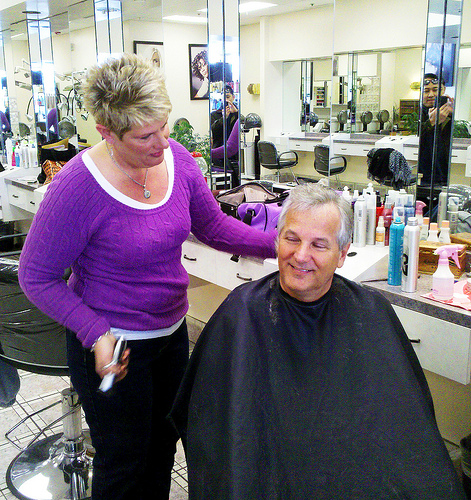<image>
Is there a cape on the man? Yes. Looking at the image, I can see the cape is positioned on top of the man, with the man providing support. Is the cape on the woman? No. The cape is not positioned on the woman. They may be near each other, but the cape is not supported by or resting on top of the woman. Is the man behind the lady? No. The man is not behind the lady. From this viewpoint, the man appears to be positioned elsewhere in the scene. Is the water bottle to the right of the hair stylist? Yes. From this viewpoint, the water bottle is positioned to the right side relative to the hair stylist. 